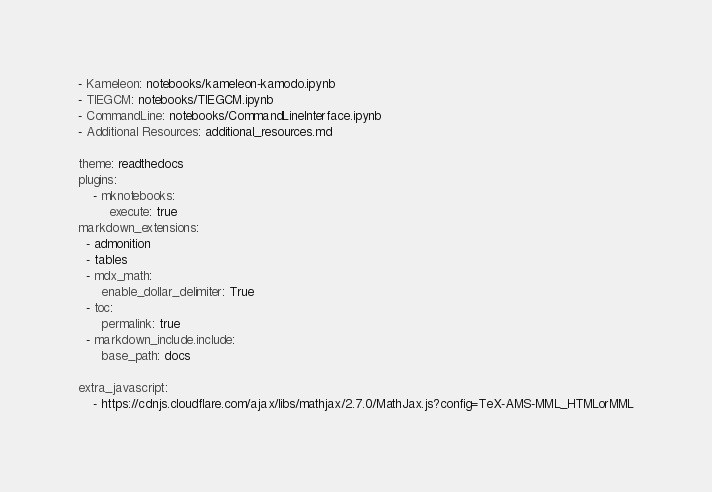<code> <loc_0><loc_0><loc_500><loc_500><_YAML_>- Kameleon: notebooks/kameleon-kamodo.ipynb
- TIEGCM: notebooks/TIEGCM.ipynb
- CommandLine: notebooks/CommandLineInterface.ipynb
- Additional Resources: additional_resources.md

theme: readthedocs
plugins:
    - mknotebooks:
        execute: true
markdown_extensions:
  - admonition
  - tables
  - mdx_math:
      enable_dollar_delimiter: True 
  - toc:
      permalink: true
  - markdown_include.include:
      base_path: docs

extra_javascript: 
    - https://cdnjs.cloudflare.com/ajax/libs/mathjax/2.7.0/MathJax.js?config=TeX-AMS-MML_HTMLorMML
</code> 